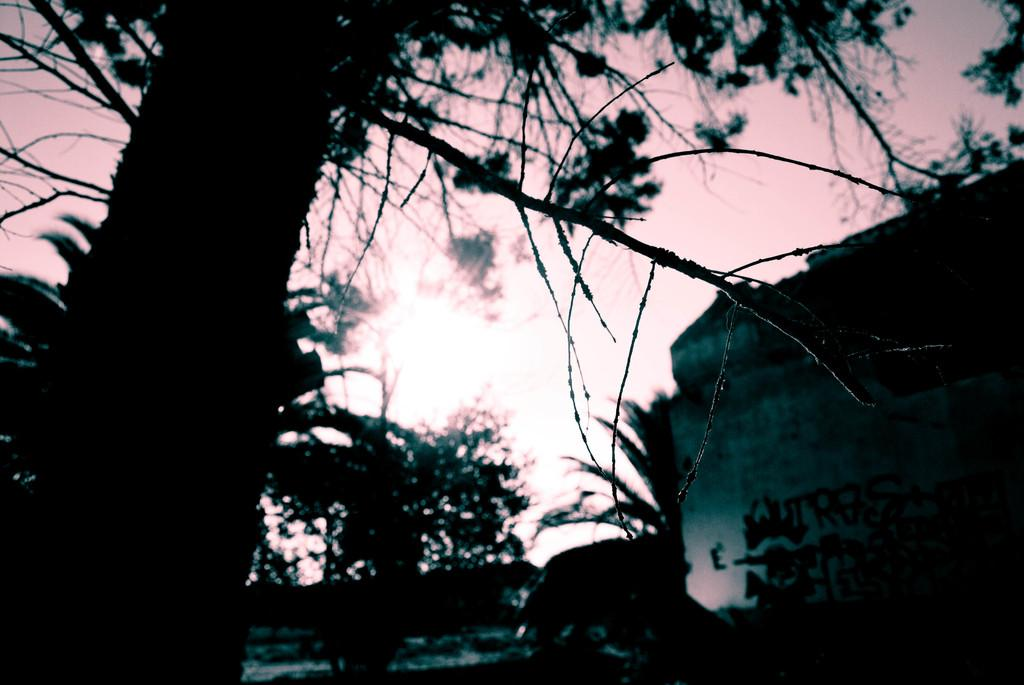What type of natural elements can be seen in the image? There are trees in the image. What type of man-made structure is visible on the right side of the image? There is a building on the right side of the image. What is the color of the sky in the image? The sky is dark in the image. Can you see the face of the person swimming in the image? There is no person swimming in the image; it features trees, a building, and a dark sky. What direction is the person walking in the image? There is no person walking in the image. 